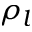<formula> <loc_0><loc_0><loc_500><loc_500>\rho _ { l }</formula> 